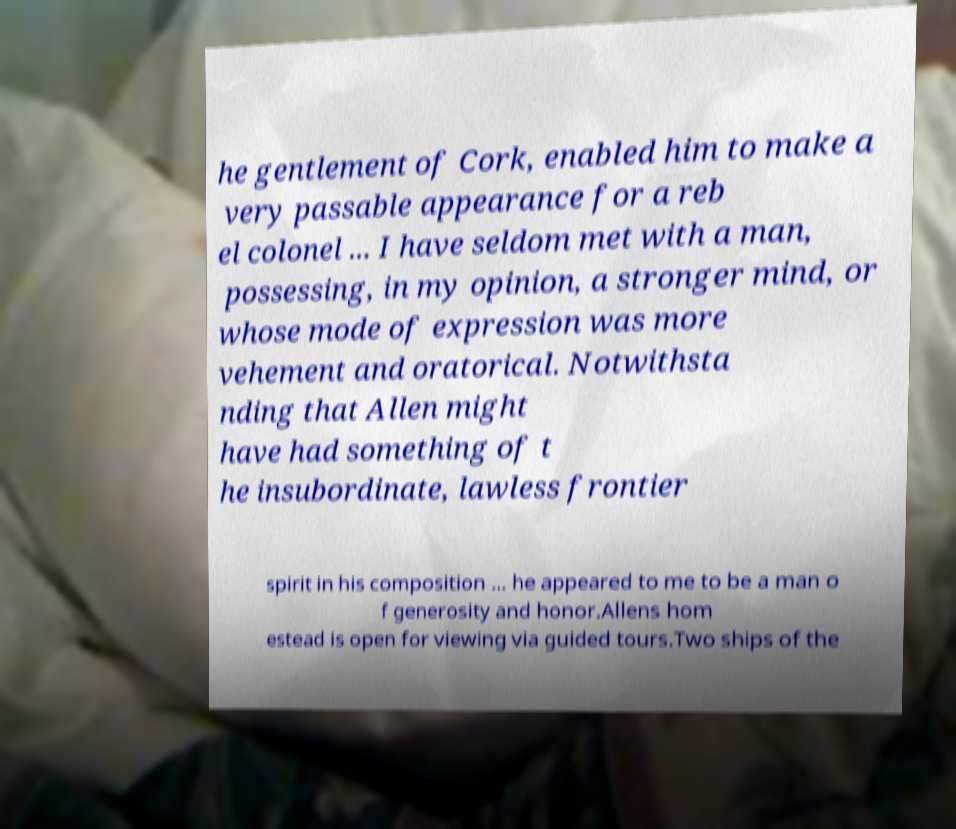Could you assist in decoding the text presented in this image and type it out clearly? he gentlement of Cork, enabled him to make a very passable appearance for a reb el colonel ... I have seldom met with a man, possessing, in my opinion, a stronger mind, or whose mode of expression was more vehement and oratorical. Notwithsta nding that Allen might have had something of t he insubordinate, lawless frontier spirit in his composition ... he appeared to me to be a man o f generosity and honor.Allens hom estead is open for viewing via guided tours.Two ships of the 